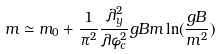<formula> <loc_0><loc_0><loc_500><loc_500>m \simeq m _ { 0 } + \frac { 1 } { \pi ^ { 2 } } \frac { \lambda _ { y } ^ { 2 } } { \lambda \varphi _ { c } ^ { 2 } } g B m \ln ( \frac { g B } { m ^ { 2 } } )</formula> 